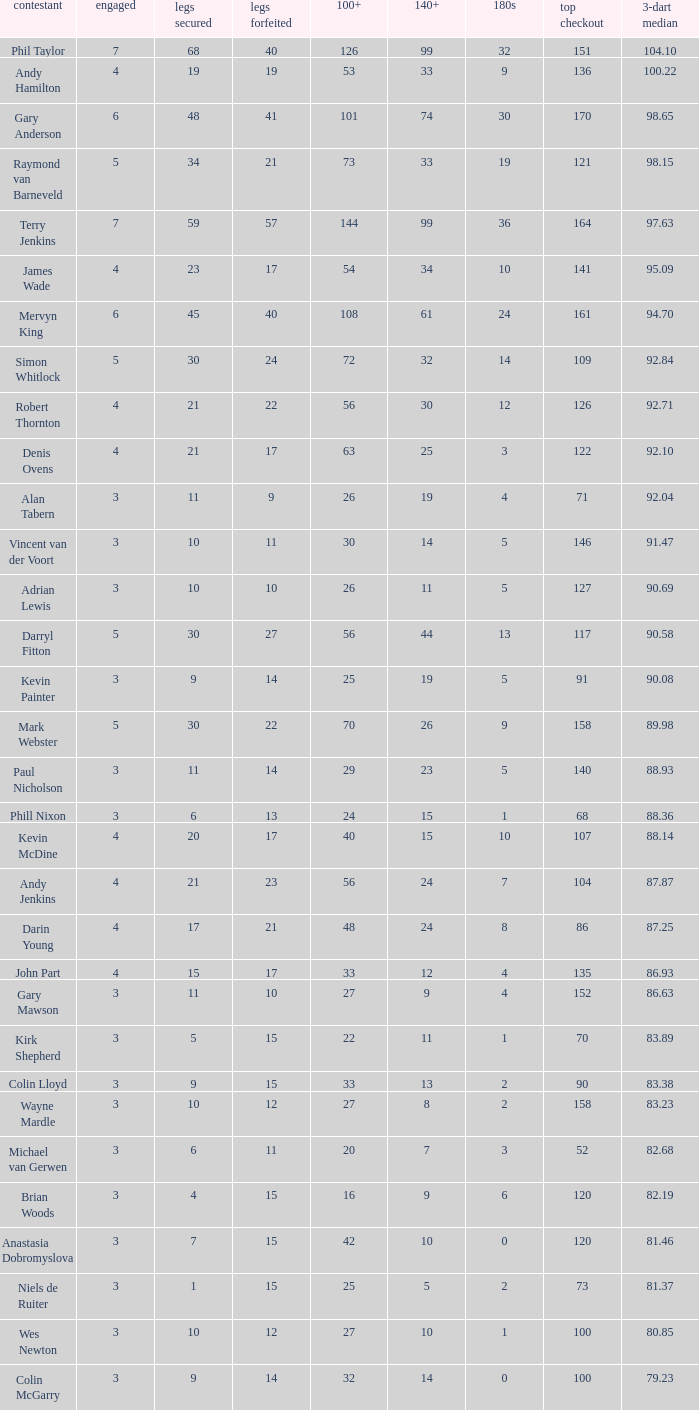What is the lowest high checkout when 140+ is 61, and played is larger than 6? None. 